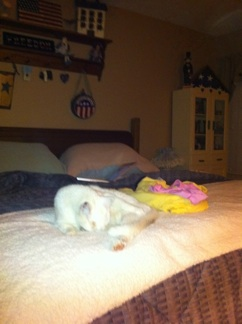What is my cat doing? Your cat is lying down on the bed, possibly resting or sleeping. 